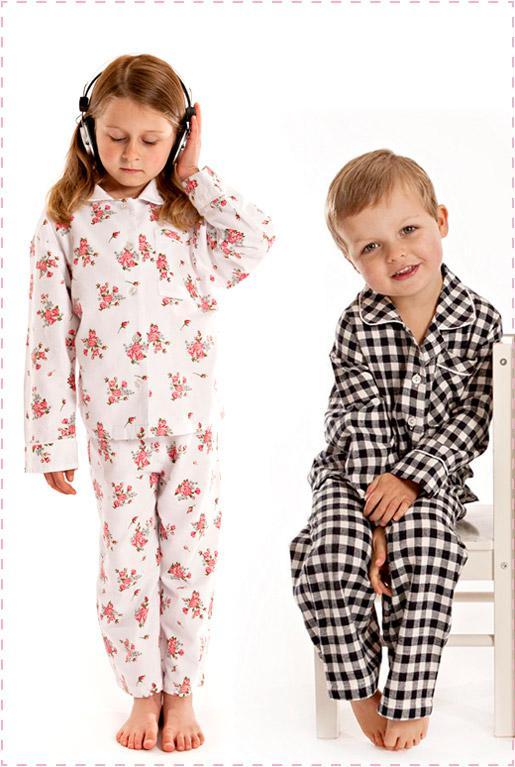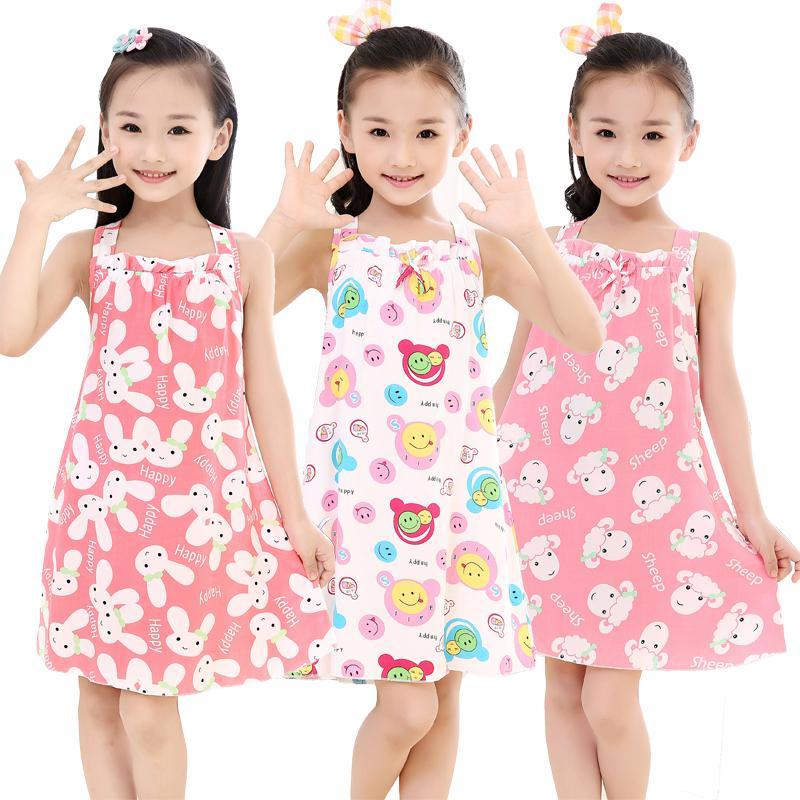The first image is the image on the left, the second image is the image on the right. Assess this claim about the two images: "The right image contains three children.". Correct or not? Answer yes or no. Yes. The first image is the image on the left, the second image is the image on the right. For the images shown, is this caption "One girl is wearing shorts." true? Answer yes or no. No. 